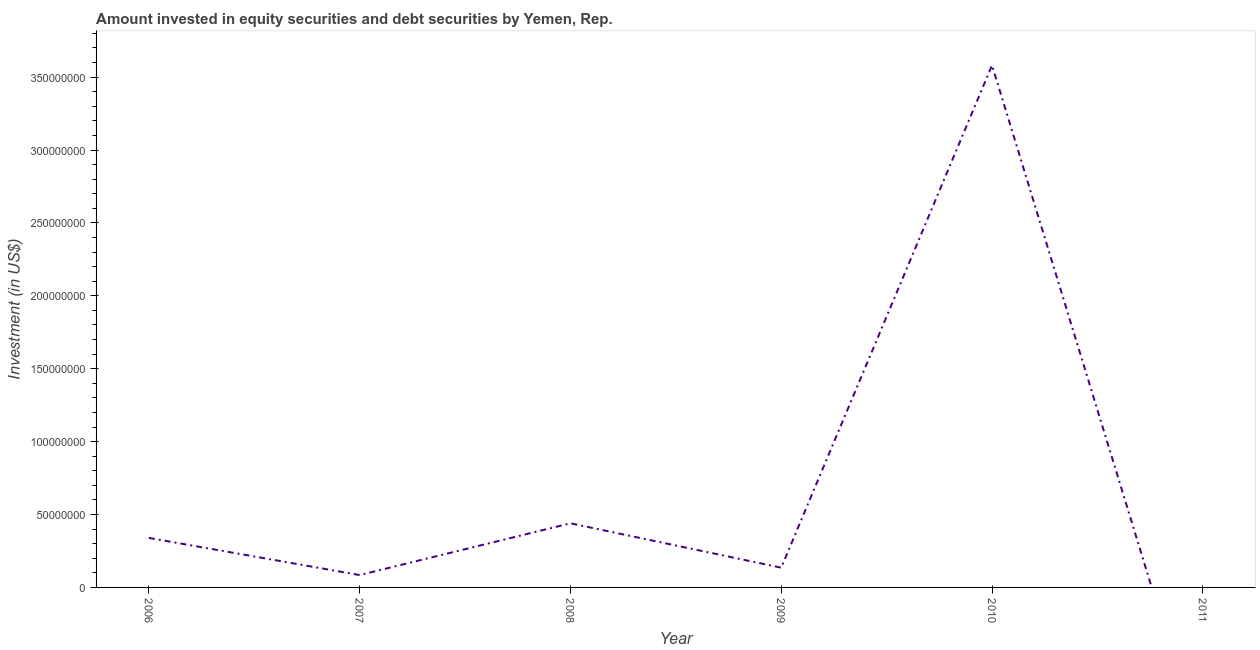What is the portfolio investment in 2006?
Your response must be concise. 3.40e+07. Across all years, what is the maximum portfolio investment?
Provide a short and direct response. 3.58e+08. Across all years, what is the minimum portfolio investment?
Offer a terse response. 0. In which year was the portfolio investment maximum?
Make the answer very short. 2010. What is the sum of the portfolio investment?
Make the answer very short. 4.58e+08. What is the difference between the portfolio investment in 2006 and 2008?
Ensure brevity in your answer.  -1.00e+07. What is the average portfolio investment per year?
Ensure brevity in your answer.  7.63e+07. What is the median portfolio investment?
Provide a succinct answer. 2.38e+07. In how many years, is the portfolio investment greater than 100000000 US$?
Make the answer very short. 1. What is the ratio of the portfolio investment in 2006 to that in 2010?
Your answer should be very brief. 0.09. Is the portfolio investment in 2006 less than that in 2008?
Make the answer very short. Yes. Is the difference between the portfolio investment in 2007 and 2008 greater than the difference between any two years?
Make the answer very short. No. What is the difference between the highest and the second highest portfolio investment?
Offer a terse response. 3.14e+08. What is the difference between the highest and the lowest portfolio investment?
Offer a very short reply. 3.58e+08. In how many years, is the portfolio investment greater than the average portfolio investment taken over all years?
Ensure brevity in your answer.  1. Does the portfolio investment monotonically increase over the years?
Provide a short and direct response. No. How many lines are there?
Offer a very short reply. 1. Are the values on the major ticks of Y-axis written in scientific E-notation?
Your answer should be compact. No. Does the graph contain any zero values?
Make the answer very short. Yes. What is the title of the graph?
Provide a succinct answer. Amount invested in equity securities and debt securities by Yemen, Rep. What is the label or title of the Y-axis?
Ensure brevity in your answer.  Investment (in US$). What is the Investment (in US$) of 2006?
Your response must be concise. 3.40e+07. What is the Investment (in US$) of 2007?
Your answer should be very brief. 8.48e+06. What is the Investment (in US$) of 2008?
Your response must be concise. 4.40e+07. What is the Investment (in US$) of 2009?
Give a very brief answer. 1.35e+07. What is the Investment (in US$) of 2010?
Keep it short and to the point. 3.58e+08. What is the difference between the Investment (in US$) in 2006 and 2007?
Keep it short and to the point. 2.55e+07. What is the difference between the Investment (in US$) in 2006 and 2008?
Your answer should be compact. -1.00e+07. What is the difference between the Investment (in US$) in 2006 and 2009?
Your answer should be very brief. 2.04e+07. What is the difference between the Investment (in US$) in 2006 and 2010?
Provide a succinct answer. -3.24e+08. What is the difference between the Investment (in US$) in 2007 and 2008?
Your answer should be very brief. -3.55e+07. What is the difference between the Investment (in US$) in 2007 and 2009?
Make the answer very short. -5.06e+06. What is the difference between the Investment (in US$) in 2007 and 2010?
Keep it short and to the point. -3.50e+08. What is the difference between the Investment (in US$) in 2008 and 2009?
Offer a very short reply. 3.04e+07. What is the difference between the Investment (in US$) in 2008 and 2010?
Offer a very short reply. -3.14e+08. What is the difference between the Investment (in US$) in 2009 and 2010?
Provide a succinct answer. -3.45e+08. What is the ratio of the Investment (in US$) in 2006 to that in 2007?
Provide a succinct answer. 4. What is the ratio of the Investment (in US$) in 2006 to that in 2008?
Your response must be concise. 0.77. What is the ratio of the Investment (in US$) in 2006 to that in 2009?
Make the answer very short. 2.51. What is the ratio of the Investment (in US$) in 2006 to that in 2010?
Your response must be concise. 0.1. What is the ratio of the Investment (in US$) in 2007 to that in 2008?
Your answer should be very brief. 0.19. What is the ratio of the Investment (in US$) in 2007 to that in 2009?
Provide a succinct answer. 0.63. What is the ratio of the Investment (in US$) in 2007 to that in 2010?
Provide a short and direct response. 0.02. What is the ratio of the Investment (in US$) in 2008 to that in 2009?
Your response must be concise. 3.25. What is the ratio of the Investment (in US$) in 2008 to that in 2010?
Your answer should be very brief. 0.12. What is the ratio of the Investment (in US$) in 2009 to that in 2010?
Provide a short and direct response. 0.04. 